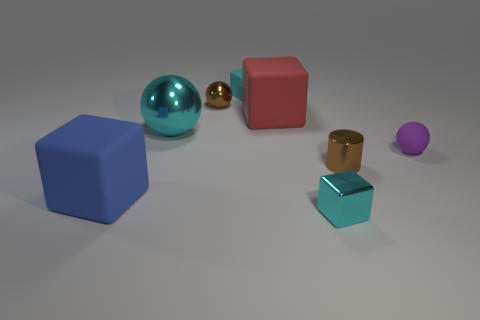What is the shape of the large cyan metallic thing in front of the large cube behind the tiny rubber ball?
Your response must be concise. Sphere. There is a metallic ball that is the same color as the tiny cylinder; what size is it?
Make the answer very short. Small. Are there any other large cubes made of the same material as the blue block?
Your answer should be compact. Yes. What material is the tiny cyan cube in front of the small purple ball?
Your response must be concise. Metal. What material is the red object?
Make the answer very short. Rubber. Is the material of the cyan block right of the large red rubber cube the same as the big sphere?
Ensure brevity in your answer.  Yes. Is the number of tiny brown metal cylinders that are in front of the tiny shiny block less than the number of purple rubber objects?
Provide a succinct answer. Yes. There is a sphere that is the same size as the red cube; what is its color?
Keep it short and to the point. Cyan. What number of other small things are the same shape as the purple matte object?
Offer a very short reply. 1. The matte cube that is in front of the tiny purple rubber thing is what color?
Ensure brevity in your answer.  Blue. 